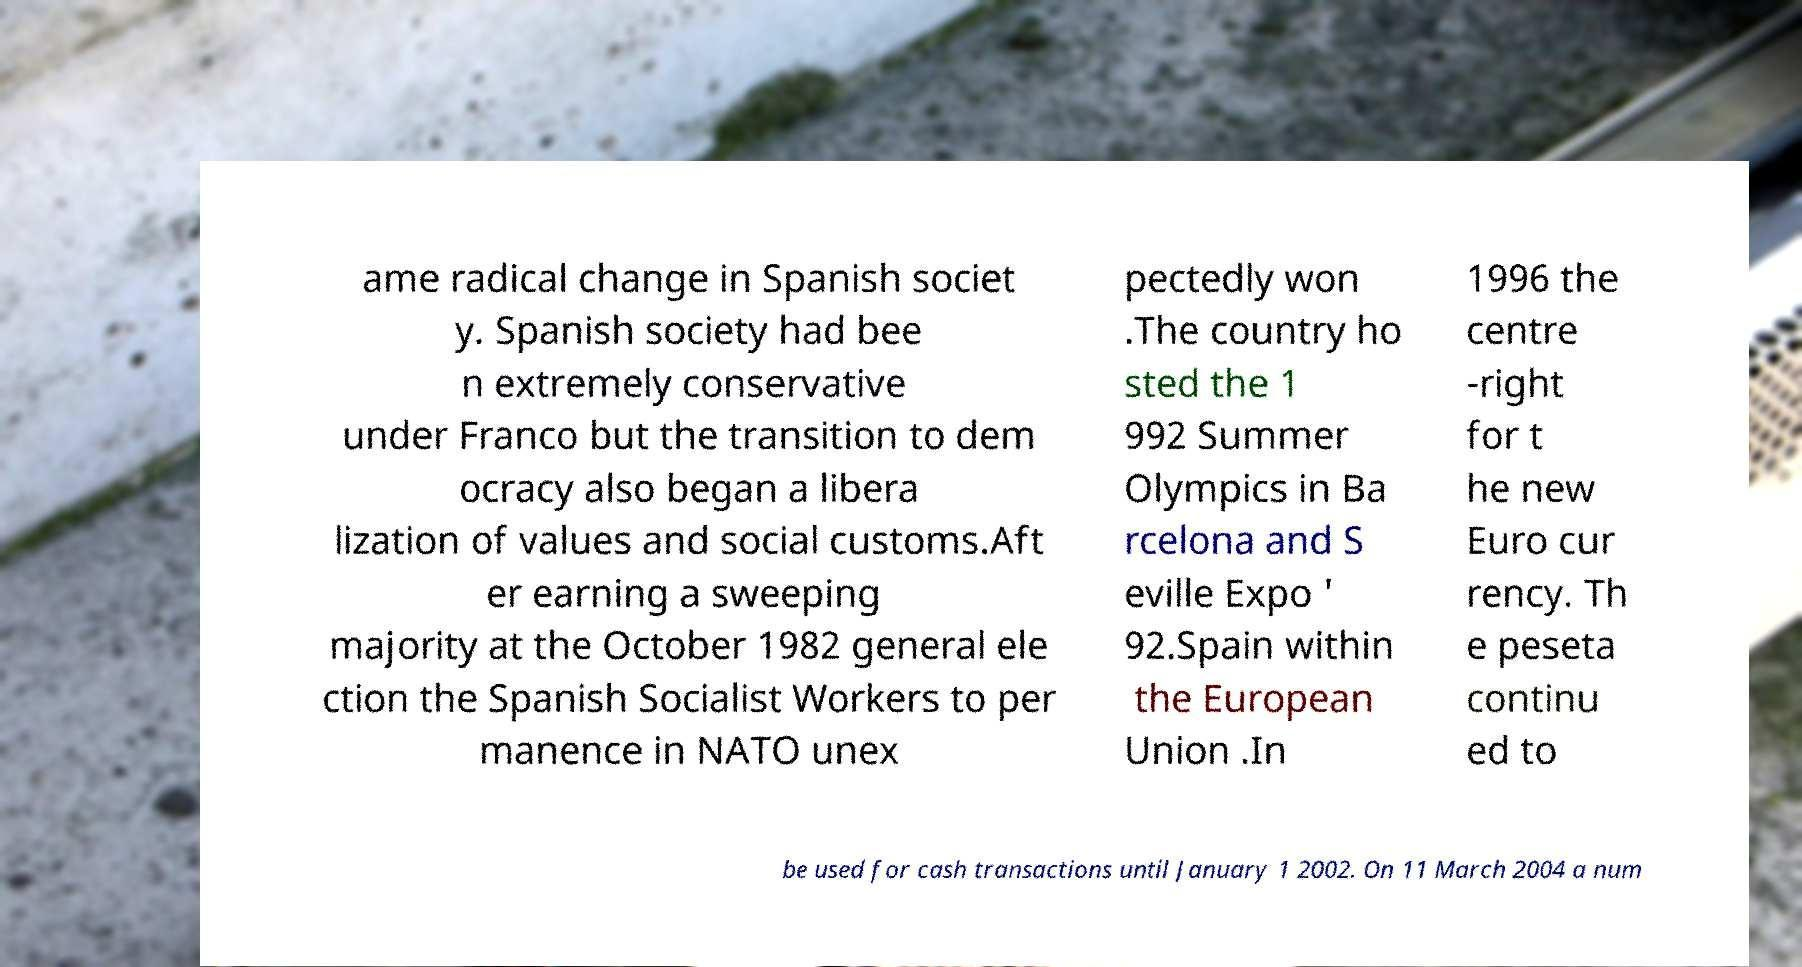Please read and relay the text visible in this image. What does it say? ame radical change in Spanish societ y. Spanish society had bee n extremely conservative under Franco but the transition to dem ocracy also began a libera lization of values and social customs.Aft er earning a sweeping majority at the October 1982 general ele ction the Spanish Socialist Workers to per manence in NATO unex pectedly won .The country ho sted the 1 992 Summer Olympics in Ba rcelona and S eville Expo ' 92.Spain within the European Union .In 1996 the centre -right for t he new Euro cur rency. Th e peseta continu ed to be used for cash transactions until January 1 2002. On 11 March 2004 a num 